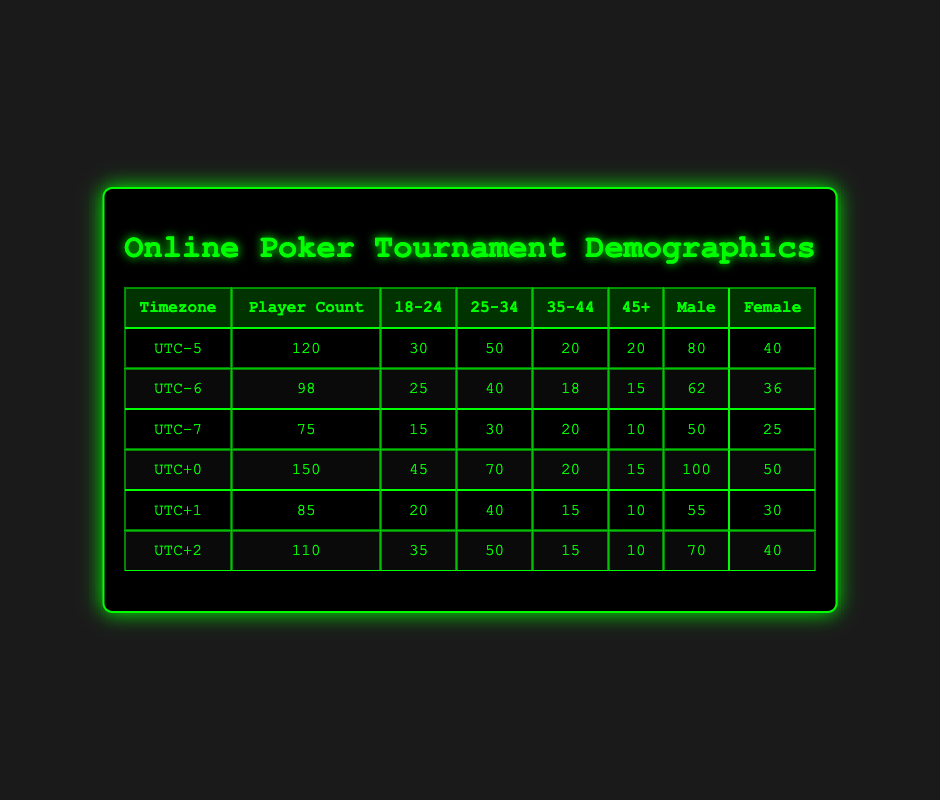What is the total player count across all timezones? To find the total player count, we sum the player counts from each timezone: (120 + 98 + 75 + 150 + 85 + 110) = 638.
Answer: 638 Which timezone has the highest number of female players? Looking at the Female column, UTC+0 has 50 female players, which is the highest compared to other timezones: UTC-5 has 40, UTC-6 has 36, UTC-7 has 25, UTC+1 has 30, and UTC+2 has 40.
Answer: UTC+0 What is the difference in male player counts between UTC-5 and UTC-7? The number of male players in UTC-5 is 80 and in UTC-7 is 50. To find the difference: 80 - 50 = 30.
Answer: 30 Is the number of players aged 18-24 more than those aged 45+ in UTC+1? In UTC+1, the number of players aged 18-24 is 20, while those aged 45+ is 10. Since 20 is greater than 10, the statement is true.
Answer: Yes What is the average player count for all timezones? To find the average, sum the player counts (638) and divide by the number of timezones (6): 638 / 6 = 106.33.
Answer: 106.33 Which age group is the most represented in UTC+2? In UTC+2, the representation by age group is: 18-24 (35), 25-34 (50), 35-44 (15), 45+ (10). The highest is the 25-34 age group with 50 players.
Answer: 25-34 How many total players are in the age group 35-44 across all timezones? We sum the 35-44 group counts from each timezone: (20 + 18 + 20 + 20 + 15 + 15) = 108.
Answer: 108 Is the total number of male players more than the total number of female players? Total males are calculated: 80 + 62 + 50 + 100 + 55 + 70 = 417. Total females: 40 + 36 + 25 + 50 + 30 + 40 = 221. Since 417 > 221, the statement is true.
Answer: Yes Which timezone has the least number of players? The least player count can be determined by comparing: UTC-7 has 75 which is the lowest among the other timezones (120, 98, 150, 85, 110).
Answer: UTC-7 